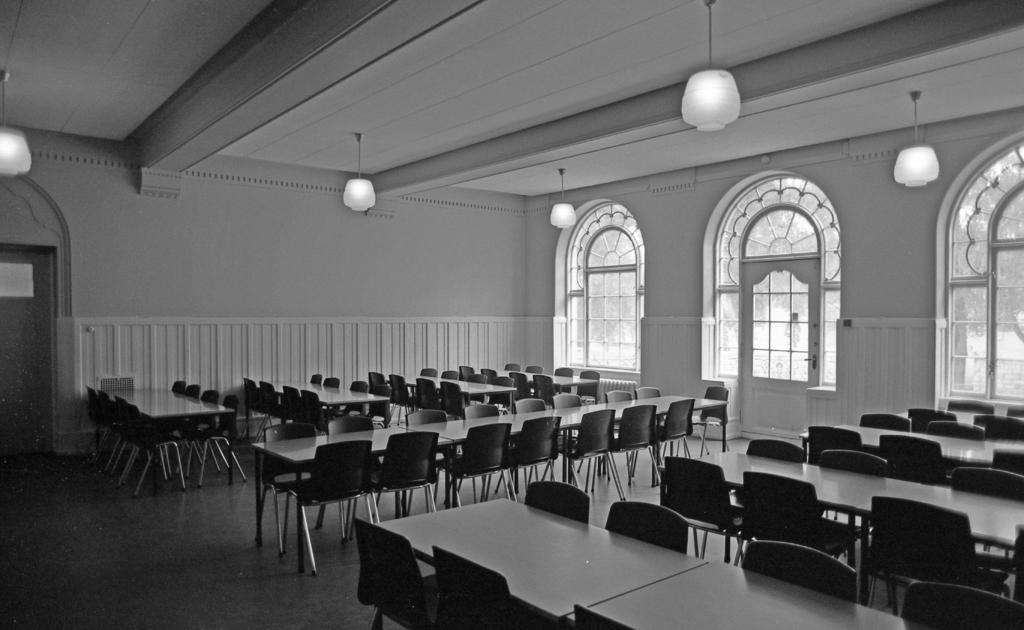Please provide a concise description of this image. This is a black and white picture. In this picture, we see many chairs and tables. On the right side, we see a white wall, glass door and the windows from which we can see the trees. On the left side, we see a door. In the background, we see a wall in white color. At the top, we see the lanterns and the ceiling of the room. 